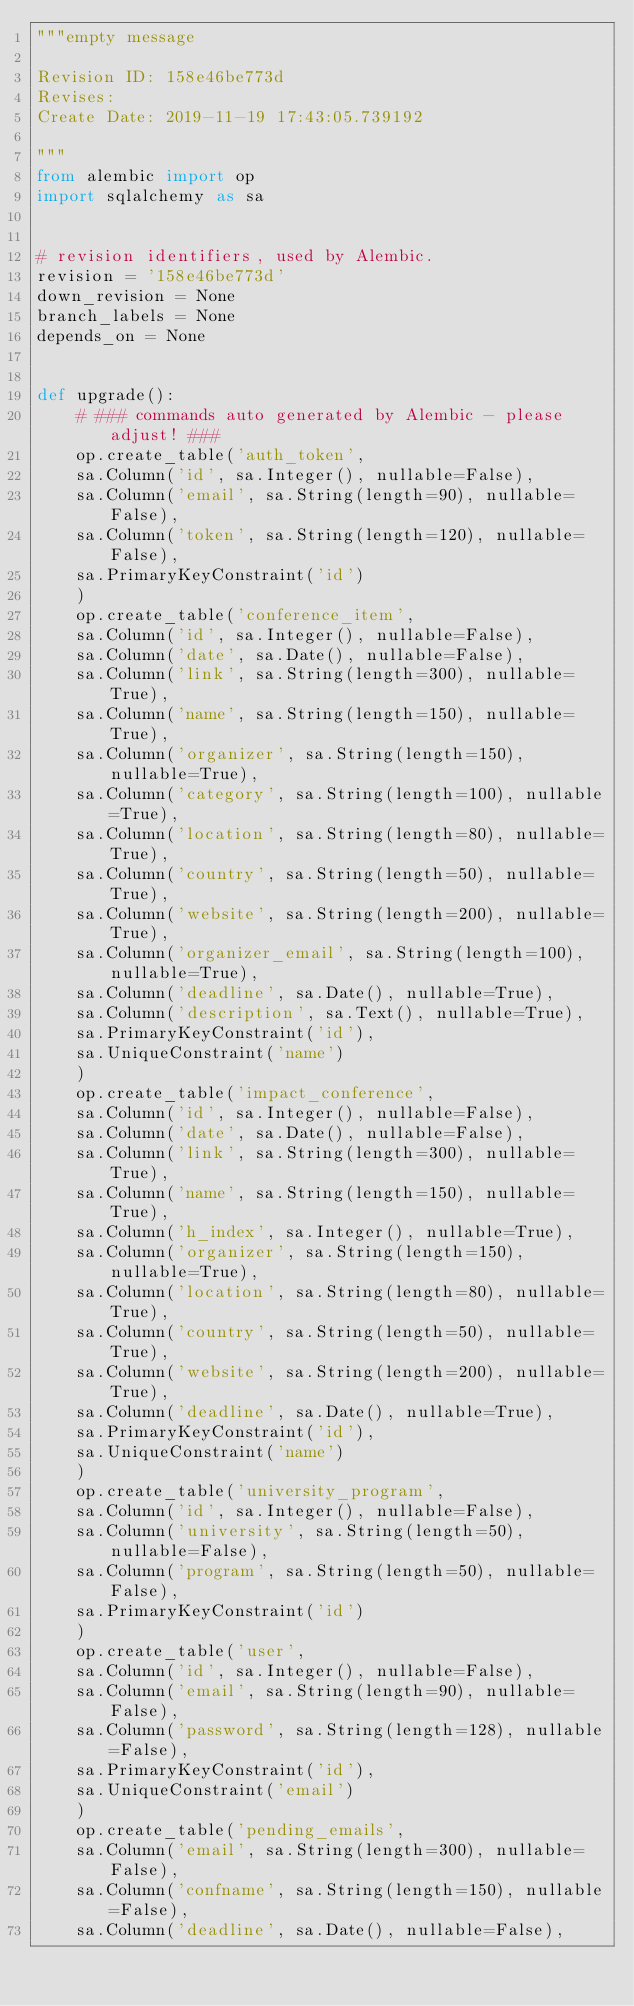<code> <loc_0><loc_0><loc_500><loc_500><_Python_>"""empty message

Revision ID: 158e46be773d
Revises: 
Create Date: 2019-11-19 17:43:05.739192

"""
from alembic import op
import sqlalchemy as sa


# revision identifiers, used by Alembic.
revision = '158e46be773d'
down_revision = None
branch_labels = None
depends_on = None


def upgrade():
    # ### commands auto generated by Alembic - please adjust! ###
    op.create_table('auth_token',
    sa.Column('id', sa.Integer(), nullable=False),
    sa.Column('email', sa.String(length=90), nullable=False),
    sa.Column('token', sa.String(length=120), nullable=False),
    sa.PrimaryKeyConstraint('id')
    )
    op.create_table('conference_item',
    sa.Column('id', sa.Integer(), nullable=False),
    sa.Column('date', sa.Date(), nullable=False),
    sa.Column('link', sa.String(length=300), nullable=True),
    sa.Column('name', sa.String(length=150), nullable=True),
    sa.Column('organizer', sa.String(length=150), nullable=True),
    sa.Column('category', sa.String(length=100), nullable=True),
    sa.Column('location', sa.String(length=80), nullable=True),
    sa.Column('country', sa.String(length=50), nullable=True),
    sa.Column('website', sa.String(length=200), nullable=True),
    sa.Column('organizer_email', sa.String(length=100), nullable=True),
    sa.Column('deadline', sa.Date(), nullable=True),
    sa.Column('description', sa.Text(), nullable=True),
    sa.PrimaryKeyConstraint('id'),
    sa.UniqueConstraint('name')
    )
    op.create_table('impact_conference',
    sa.Column('id', sa.Integer(), nullable=False),
    sa.Column('date', sa.Date(), nullable=False),
    sa.Column('link', sa.String(length=300), nullable=True),
    sa.Column('name', sa.String(length=150), nullable=True),
    sa.Column('h_index', sa.Integer(), nullable=True),
    sa.Column('organizer', sa.String(length=150), nullable=True),
    sa.Column('location', sa.String(length=80), nullable=True),
    sa.Column('country', sa.String(length=50), nullable=True),
    sa.Column('website', sa.String(length=200), nullable=True),
    sa.Column('deadline', sa.Date(), nullable=True),
    sa.PrimaryKeyConstraint('id'),
    sa.UniqueConstraint('name')
    )
    op.create_table('university_program',
    sa.Column('id', sa.Integer(), nullable=False),
    sa.Column('university', sa.String(length=50), nullable=False),
    sa.Column('program', sa.String(length=50), nullable=False),
    sa.PrimaryKeyConstraint('id')
    )
    op.create_table('user',
    sa.Column('id', sa.Integer(), nullable=False),
    sa.Column('email', sa.String(length=90), nullable=False),
    sa.Column('password', sa.String(length=128), nullable=False),
    sa.PrimaryKeyConstraint('id'),
    sa.UniqueConstraint('email')
    )
    op.create_table('pending_emails',
    sa.Column('email', sa.String(length=300), nullable=False),
    sa.Column('confname', sa.String(length=150), nullable=False),
    sa.Column('deadline', sa.Date(), nullable=False),</code> 